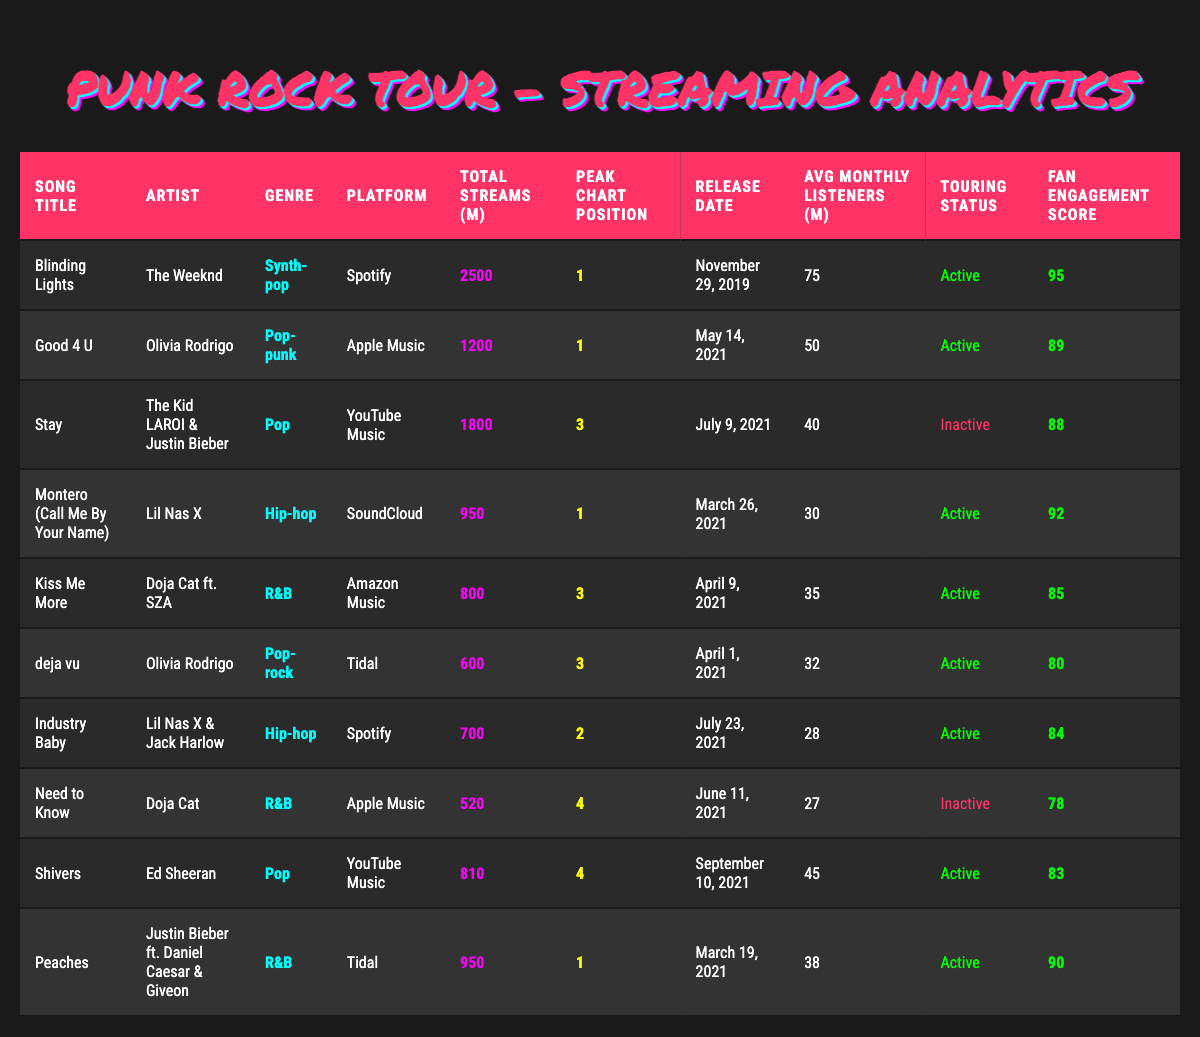What song has the highest total streams? "Blinding Lights" shows the highest total streams with 2500 million.
Answer: Blinding Lights Which song by Olivia Rodrigo has the higher fan engagement score? "Good 4 U" has a fan engagement score of 89, while "deja vu" has a score of 80, so "Good 4 U" is higher.
Answer: Good 4 U How many songs have a peak chart position of 1? There are four songs with a peak chart position of 1: "Blinding Lights," "Good 4 U," "Montero," and "Peaches."
Answer: Four What is the average number of average monthly listeners for all songs? Summing all average monthly listeners gives a total of (75 + 50 + 40 + 30 + 35 + 32 + 28 + 27 + 45 + 38) = 400 million. There are 10 songs, so the average is 400 / 10 = 40 million.
Answer: 40 million Which platform has the most songs listed? Spotify has three songs listed: "Blinding Lights," "Industry Baby," and "Stay."
Answer: Spotify Do any songs have "Inactive" touring status? Yes, "Stay" and "Need to Know" have an inactive touring status.
Answer: Yes Which genre has the highest peak chart position in the table? The highest peak chart position is 1, achieved by songs from multiple genres including Synth-pop, Pop-punk, Hip-hop, and R&B. The specific genres achieving this are "Blinding Lights," "Good 4 U," "Montero," and "Peaches."
Answer: 1 What is the total number of streams for songs in the R&B genre? The total streams for R&B songs are "Kiss Me More" (800) + "Peaches" (950) + "Need to Know" (520) = 2270 million.
Answer: 2270 million Is there any song that has more than 1,000 million streams and a fan engagement score lower than 85? "Industry Baby" has 700 million streams and a fan engagement score of 84, which is lower than 85. Since it does not exceed 1,000 million streams, the answer is no.
Answer: No Which song has the lowest total streams? "Need to Know" has the lowest total streams at 520 million.
Answer: Need to Know 